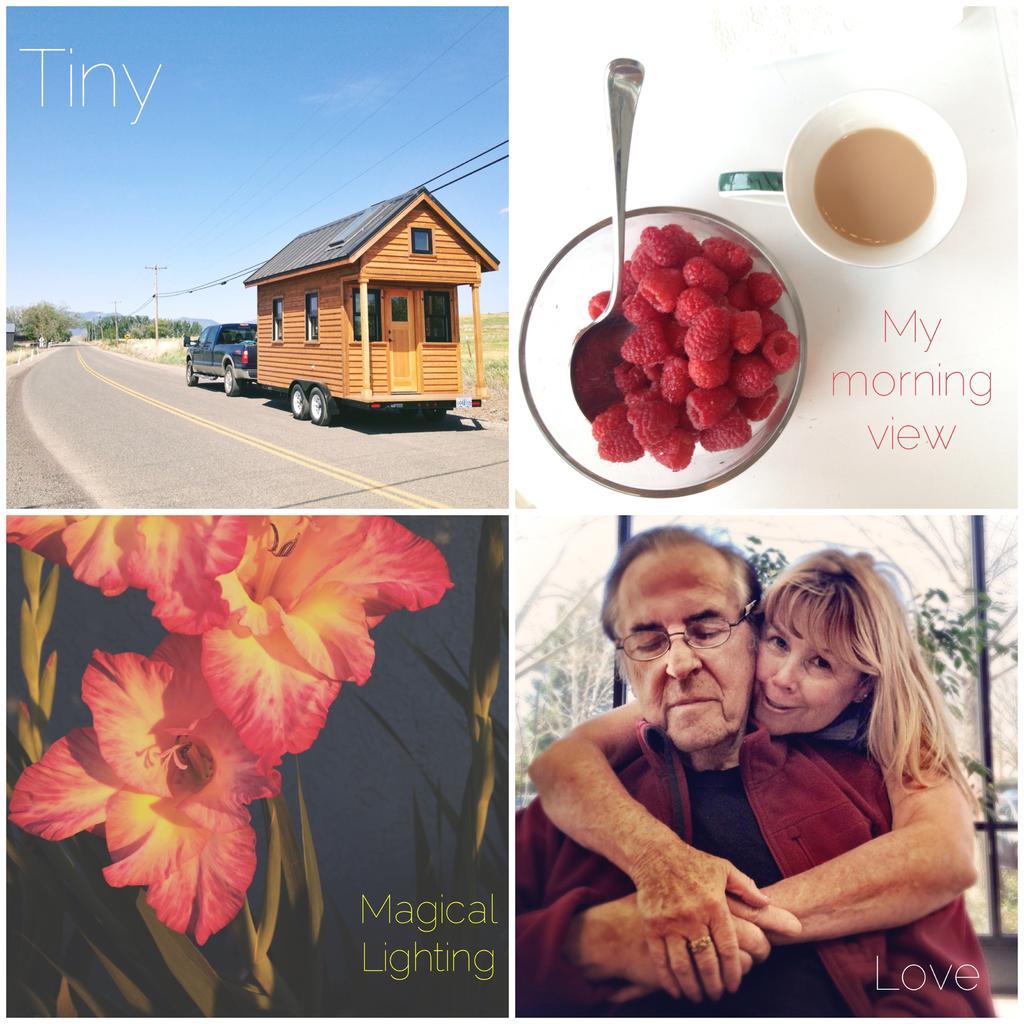Could you give a brief overview of what you see in this image? This is a collage picture. In this picture we can see two people, flowers, trees, poles, vehicle on the road, shed, bowl, strawberries, spoon, cup, some text and the sky. 